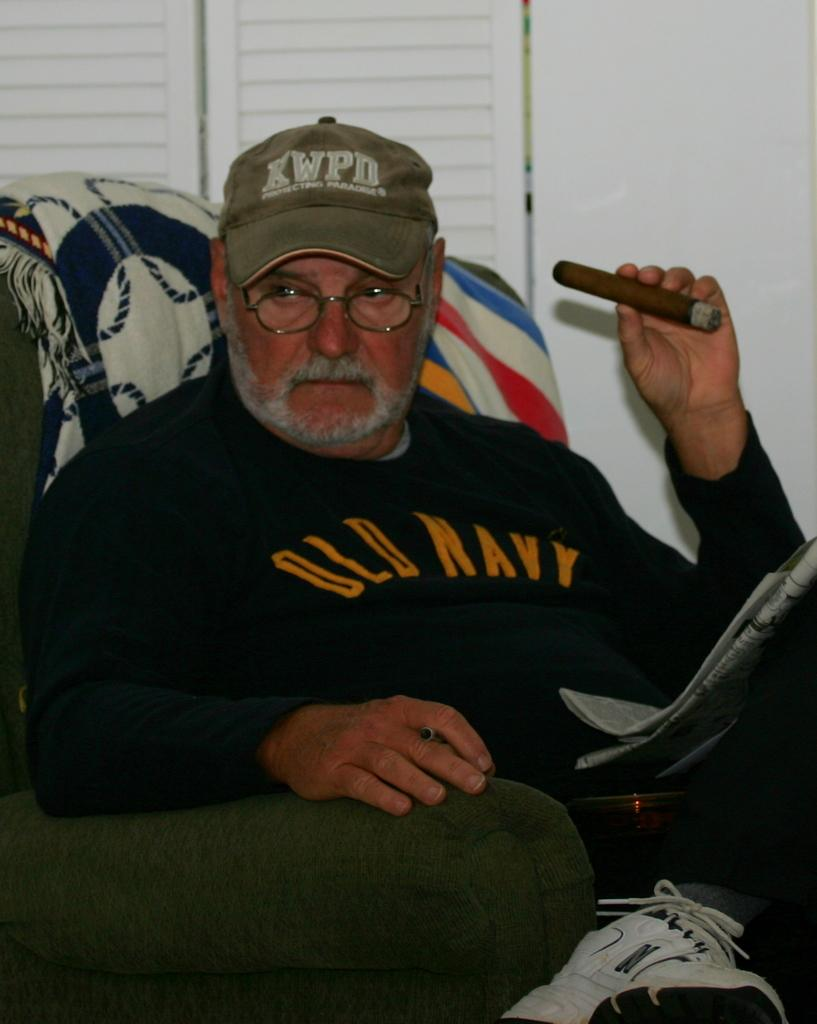<image>
Render a clear and concise summary of the photo. A man holding a cigar wearing an Old Navy shirt 